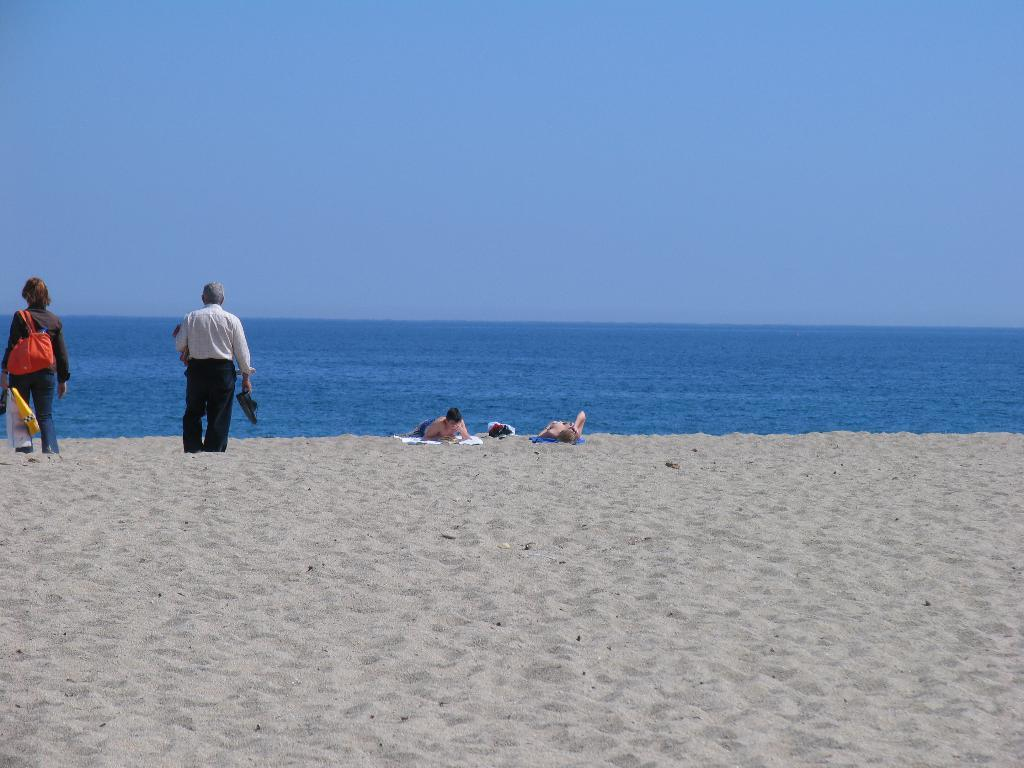What is the setting of the image? The setting of the image is a beach. Can you describe the people in the image? There are persons on the beach in the image. Where is the person located on the left side of the image? The person on the left side of the image is wearing a bag. What is visible at the top of the image? There is a sky visible at the top of the image. What type of instrument is the rat playing on the beach in the image? There is no rat or instrument present in the image. 